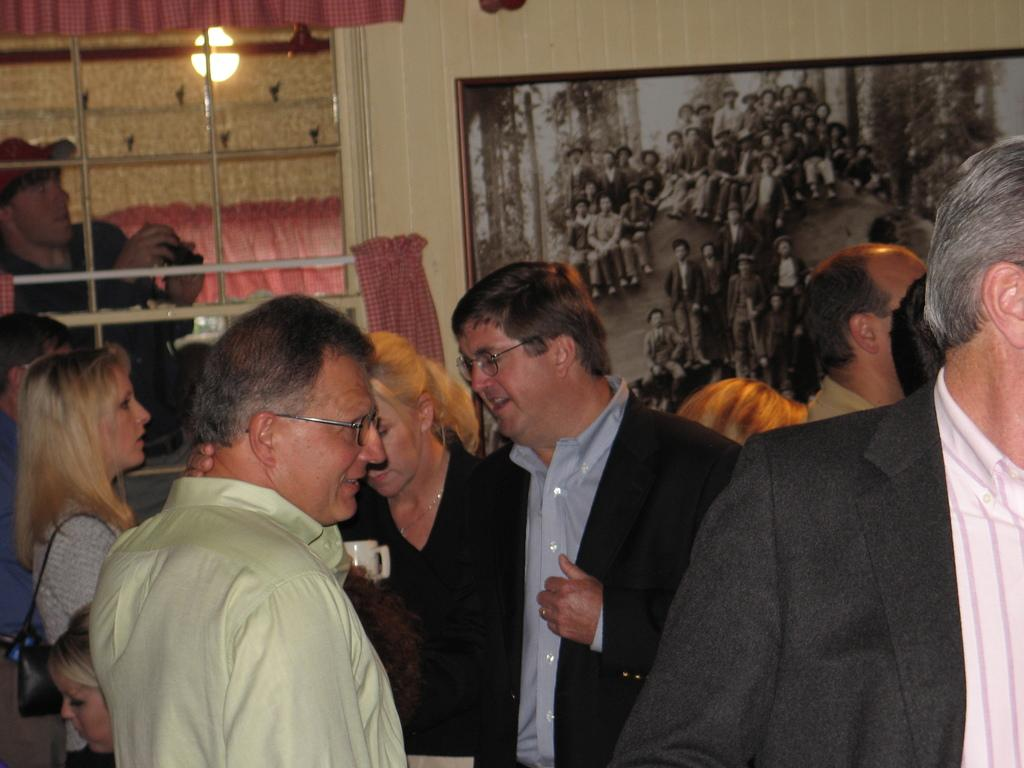How many people are in the image? There is a group of people standing in the image. What is the background of the image? There is a wall in the image. Is there any opening in the wall? Yes, there is a window in the image. What is providing illumination in the image? There is a light in the image. Is there any decorative item in the image? Yes, there is a photo frame in the image. What type of office division can be seen in the image? There is no office division present in the image. What color is the light in the image? The provided facts do not mention the color of the light in the image. 